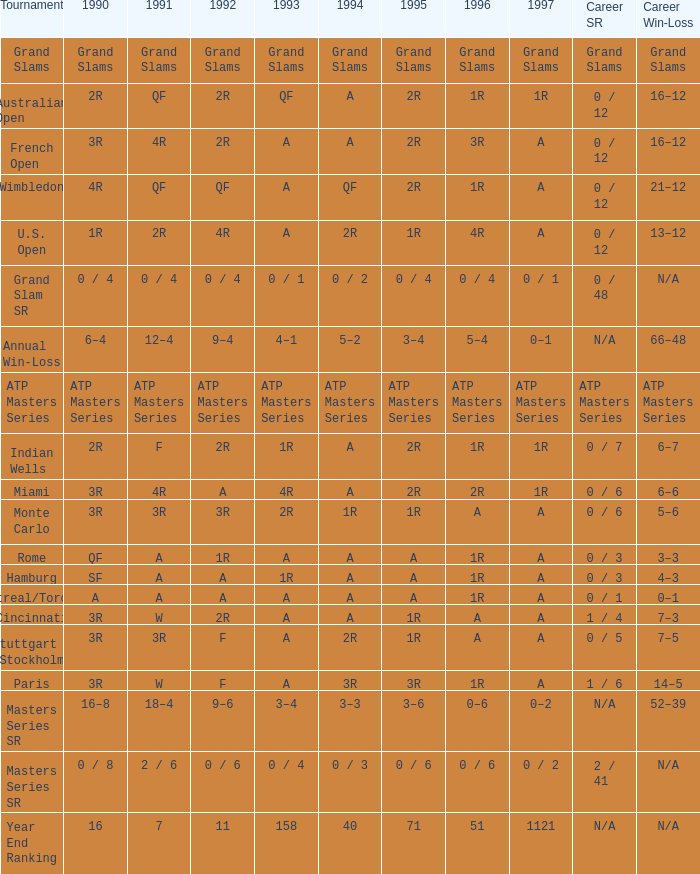What is Tournament, when Career SR is "ATP Masters Series"? ATP Masters Series. Parse the table in full. {'header': ['Tournament', '1990', '1991', '1992', '1993', '1994', '1995', '1996', '1997', 'Career SR', 'Career Win-Loss'], 'rows': [['Grand Slams', 'Grand Slams', 'Grand Slams', 'Grand Slams', 'Grand Slams', 'Grand Slams', 'Grand Slams', 'Grand Slams', 'Grand Slams', 'Grand Slams', 'Grand Slams'], ['Australian Open', '2R', 'QF', '2R', 'QF', 'A', '2R', '1R', '1R', '0 / 12', '16–12'], ['French Open', '3R', '4R', '2R', 'A', 'A', '2R', '3R', 'A', '0 / 12', '16–12'], ['Wimbledon', '4R', 'QF', 'QF', 'A', 'QF', '2R', '1R', 'A', '0 / 12', '21–12'], ['U.S. Open', '1R', '2R', '4R', 'A', '2R', '1R', '4R', 'A', '0 / 12', '13–12'], ['Grand Slam SR', '0 / 4', '0 / 4', '0 / 4', '0 / 1', '0 / 2', '0 / 4', '0 / 4', '0 / 1', '0 / 48', 'N/A'], ['Annual Win-Loss', '6–4', '12–4', '9–4', '4–1', '5–2', '3–4', '5–4', '0–1', 'N/A', '66–48'], ['ATP Masters Series', 'ATP Masters Series', 'ATP Masters Series', 'ATP Masters Series', 'ATP Masters Series', 'ATP Masters Series', 'ATP Masters Series', 'ATP Masters Series', 'ATP Masters Series', 'ATP Masters Series', 'ATP Masters Series'], ['Indian Wells', '2R', 'F', '2R', '1R', 'A', '2R', '1R', '1R', '0 / 7', '6–7'], ['Miami', '3R', '4R', 'A', '4R', 'A', '2R', '2R', '1R', '0 / 6', '6–6'], ['Monte Carlo', '3R', '3R', '3R', '2R', '1R', '1R', 'A', 'A', '0 / 6', '5–6'], ['Rome', 'QF', 'A', '1R', 'A', 'A', 'A', '1R', 'A', '0 / 3', '3–3'], ['Hamburg', 'SF', 'A', 'A', '1R', 'A', 'A', '1R', 'A', '0 / 3', '4–3'], ['Montreal/Toronto', 'A', 'A', 'A', 'A', 'A', 'A', '1R', 'A', '0 / 1', '0–1'], ['Cincinnati', '3R', 'W', '2R', 'A', 'A', '1R', 'A', 'A', '1 / 4', '7–3'], ['Stuttgart (Stockholm)', '3R', '3R', 'F', 'A', '2R', '1R', 'A', 'A', '0 / 5', '7–5'], ['Paris', '3R', 'W', 'F', 'A', '3R', '3R', '1R', 'A', '1 / 6', '14–5'], ['Masters Series SR', '16–8', '18–4', '9–6', '3–4', '3–3', '3–6', '0–6', '0–2', 'N/A', '52–39'], ['Masters Series SR', '0 / 8', '2 / 6', '0 / 6', '0 / 4', '0 / 3', '0 / 6', '0 / 6', '0 / 2', '2 / 41', 'N/A'], ['Year End Ranking', '16', '7', '11', '158', '40', '71', '51', '1121', 'N/A', 'N/A']]} 